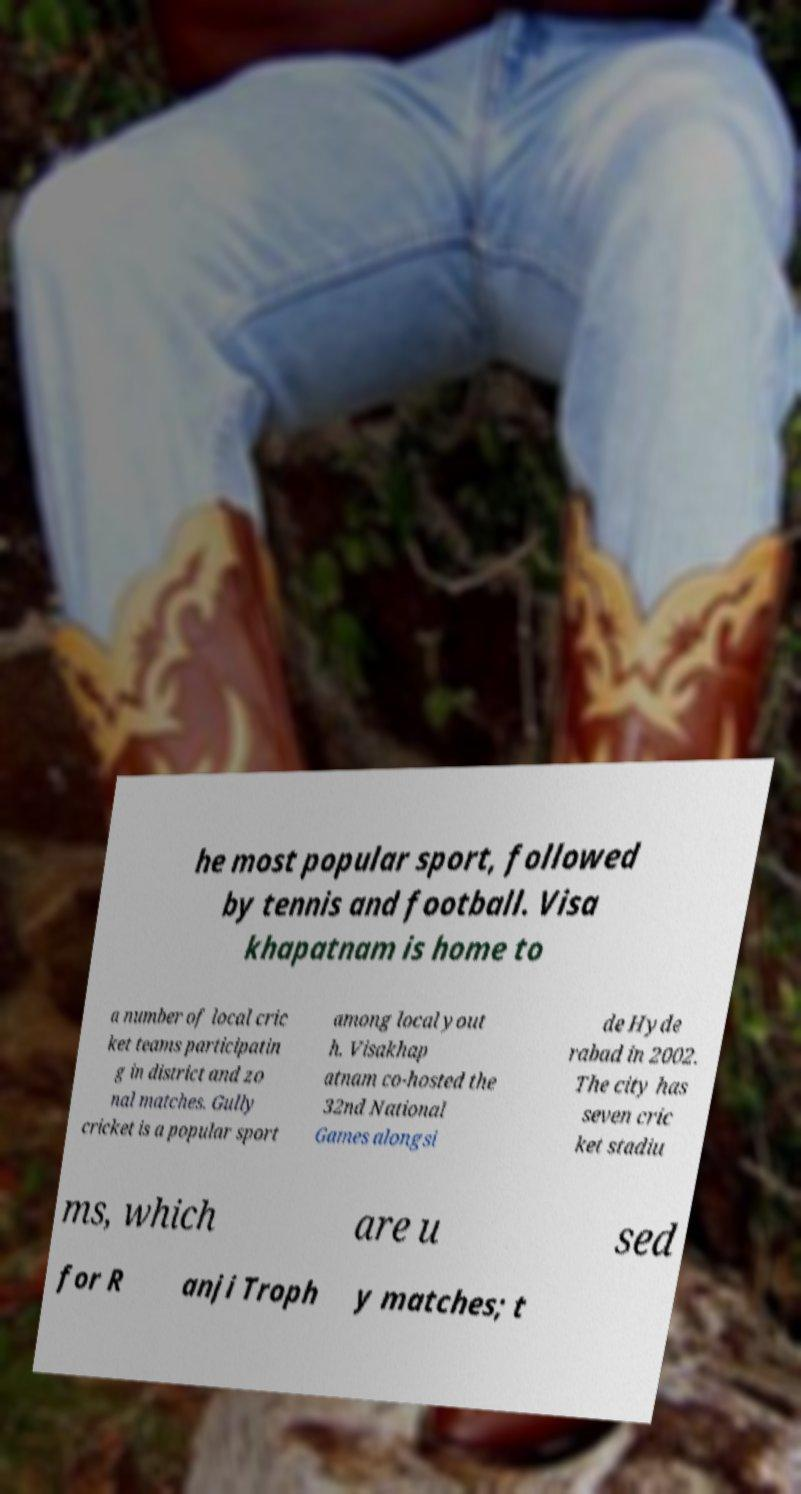Can you accurately transcribe the text from the provided image for me? he most popular sport, followed by tennis and football. Visa khapatnam is home to a number of local cric ket teams participatin g in district and zo nal matches. Gully cricket is a popular sport among local yout h. Visakhap atnam co-hosted the 32nd National Games alongsi de Hyde rabad in 2002. The city has seven cric ket stadiu ms, which are u sed for R anji Troph y matches; t 